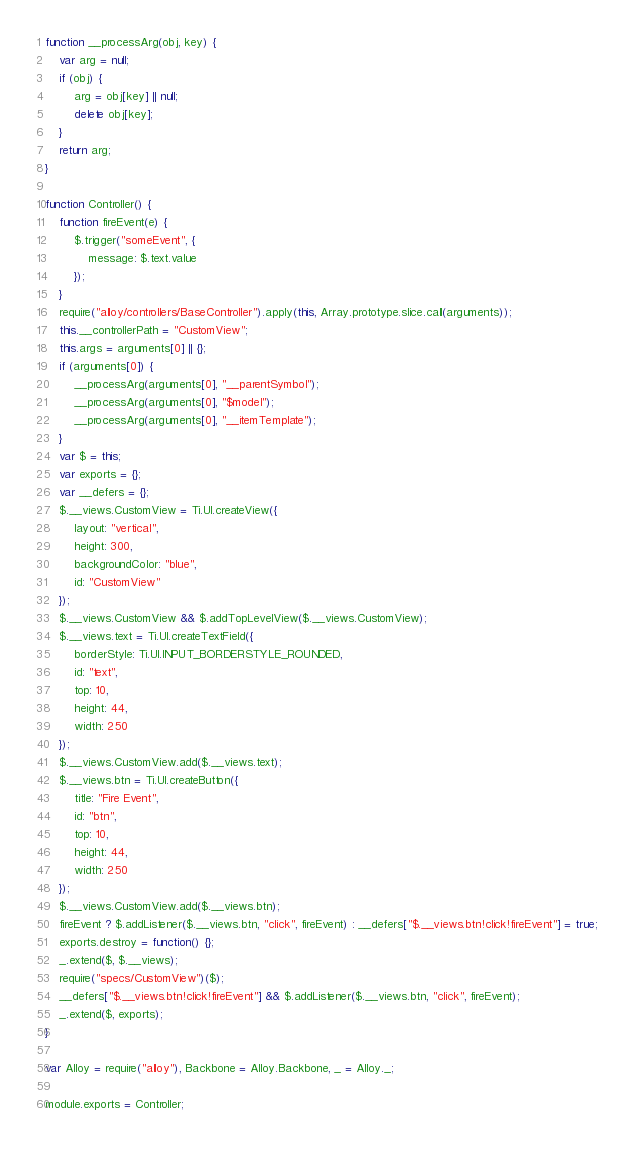Convert code to text. <code><loc_0><loc_0><loc_500><loc_500><_JavaScript_>function __processArg(obj, key) {
    var arg = null;
    if (obj) {
        arg = obj[key] || null;
        delete obj[key];
    }
    return arg;
}

function Controller() {
    function fireEvent(e) {
        $.trigger("someEvent", {
            message: $.text.value
        });
    }
    require("alloy/controllers/BaseController").apply(this, Array.prototype.slice.call(arguments));
    this.__controllerPath = "CustomView";
    this.args = arguments[0] || {};
    if (arguments[0]) {
        __processArg(arguments[0], "__parentSymbol");
        __processArg(arguments[0], "$model");
        __processArg(arguments[0], "__itemTemplate");
    }
    var $ = this;
    var exports = {};
    var __defers = {};
    $.__views.CustomView = Ti.UI.createView({
        layout: "vertical",
        height: 300,
        backgroundColor: "blue",
        id: "CustomView"
    });
    $.__views.CustomView && $.addTopLevelView($.__views.CustomView);
    $.__views.text = Ti.UI.createTextField({
        borderStyle: Ti.UI.INPUT_BORDERSTYLE_ROUNDED,
        id: "text",
        top: 10,
        height: 44,
        width: 250
    });
    $.__views.CustomView.add($.__views.text);
    $.__views.btn = Ti.UI.createButton({
        title: "Fire Event",
        id: "btn",
        top: 10,
        height: 44,
        width: 250
    });
    $.__views.CustomView.add($.__views.btn);
    fireEvent ? $.addListener($.__views.btn, "click", fireEvent) : __defers["$.__views.btn!click!fireEvent"] = true;
    exports.destroy = function() {};
    _.extend($, $.__views);
    require("specs/CustomView")($);
    __defers["$.__views.btn!click!fireEvent"] && $.addListener($.__views.btn, "click", fireEvent);
    _.extend($, exports);
}

var Alloy = require("alloy"), Backbone = Alloy.Backbone, _ = Alloy._;

module.exports = Controller;</code> 